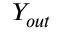Convert formula to latex. <formula><loc_0><loc_0><loc_500><loc_500>Y _ { o u t }</formula> 